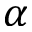<formula> <loc_0><loc_0><loc_500><loc_500>\alpha</formula> 